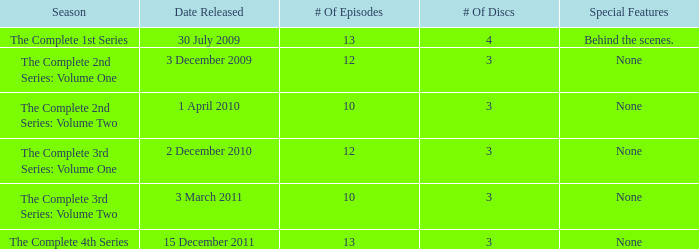I'm looking to parse the entire table for insights. Could you assist me with that? {'header': ['Season', 'Date Released', '# Of Episodes', '# Of Discs', 'Special Features'], 'rows': [['The Complete 1st Series', '30 July 2009', '13', '4', 'Behind the scenes.'], ['The Complete 2nd Series: Volume One', '3 December 2009', '12', '3', 'None'], ['The Complete 2nd Series: Volume Two', '1 April 2010', '10', '3', 'None'], ['The Complete 3rd Series: Volume One', '2 December 2010', '12', '3', 'None'], ['The Complete 3rd Series: Volume Two', '3 March 2011', '10', '3', 'None'], ['The Complete 4th Series', '15 December 2011', '13', '3', 'None']]} How many discs for the complete 4th series? 3.0. 